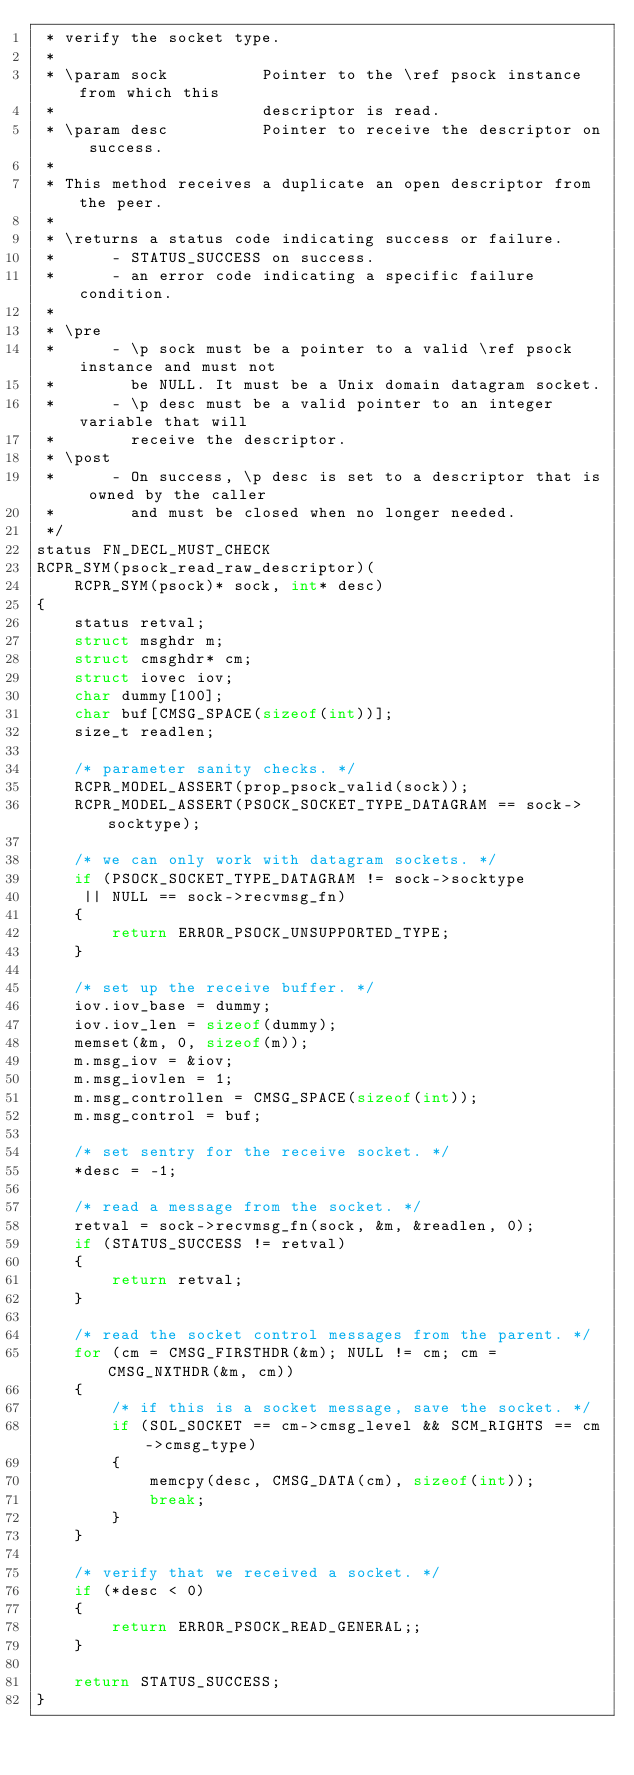<code> <loc_0><loc_0><loc_500><loc_500><_C_> * verify the socket type.
 *
 * \param sock          Pointer to the \ref psock instance from which this
 *                      descriptor is read.
 * \param desc          Pointer to receive the descriptor on success.
 *
 * This method receives a duplicate an open descriptor from the peer.
 *
 * \returns a status code indicating success or failure.
 *      - STATUS_SUCCESS on success.
 *      - an error code indicating a specific failure condition.
 *
 * \pre
 *      - \p sock must be a pointer to a valid \ref psock instance and must not
 *        be NULL. It must be a Unix domain datagram socket.
 *      - \p desc must be a valid pointer to an integer variable that will
 *        receive the descriptor.
 * \post
 *      - On success, \p desc is set to a descriptor that is owned by the caller
 *        and must be closed when no longer needed.
 */
status FN_DECL_MUST_CHECK
RCPR_SYM(psock_read_raw_descriptor)(
    RCPR_SYM(psock)* sock, int* desc)
{
    status retval;
    struct msghdr m;
    struct cmsghdr* cm;
    struct iovec iov;
    char dummy[100];
    char buf[CMSG_SPACE(sizeof(int))];
    size_t readlen;

    /* parameter sanity checks. */
    RCPR_MODEL_ASSERT(prop_psock_valid(sock));
    RCPR_MODEL_ASSERT(PSOCK_SOCKET_TYPE_DATAGRAM == sock->socktype);

    /* we can only work with datagram sockets. */
    if (PSOCK_SOCKET_TYPE_DATAGRAM != sock->socktype
     || NULL == sock->recvmsg_fn)
    {
        return ERROR_PSOCK_UNSUPPORTED_TYPE;
    }

    /* set up the receive buffer. */
    iov.iov_base = dummy;
    iov.iov_len = sizeof(dummy);
    memset(&m, 0, sizeof(m));
    m.msg_iov = &iov;
    m.msg_iovlen = 1;
    m.msg_controllen = CMSG_SPACE(sizeof(int));
    m.msg_control = buf;

    /* set sentry for the receive socket. */
    *desc = -1;

    /* read a message from the socket. */
    retval = sock->recvmsg_fn(sock, &m, &readlen, 0);
    if (STATUS_SUCCESS != retval)
    {
        return retval;
    }

    /* read the socket control messages from the parent. */
    for (cm = CMSG_FIRSTHDR(&m); NULL != cm; cm = CMSG_NXTHDR(&m, cm))
    {
        /* if this is a socket message, save the socket. */
        if (SOL_SOCKET == cm->cmsg_level && SCM_RIGHTS == cm->cmsg_type)
        {
            memcpy(desc, CMSG_DATA(cm), sizeof(int));
            break;
        }
    }

    /* verify that we received a socket. */
    if (*desc < 0)
    {
        return ERROR_PSOCK_READ_GENERAL;;
    }

    return STATUS_SUCCESS;
}
</code> 